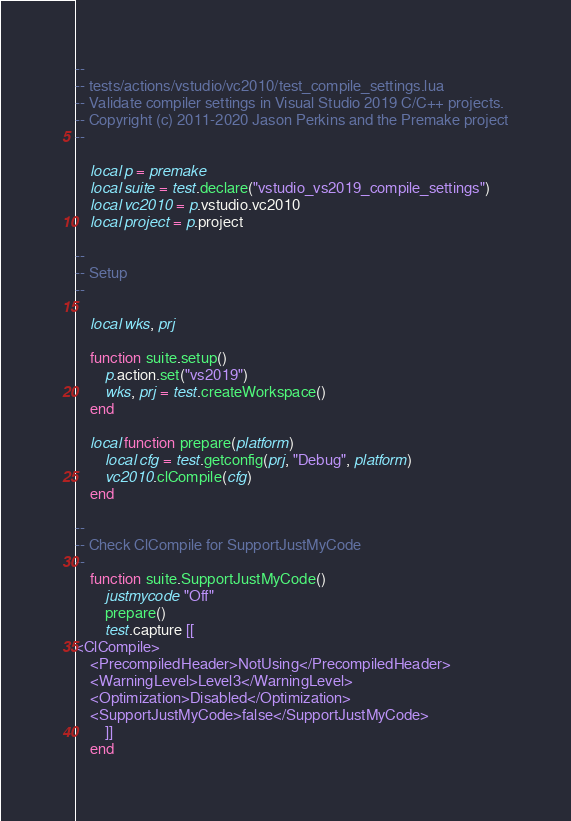<code> <loc_0><loc_0><loc_500><loc_500><_Lua_>--
-- tests/actions/vstudio/vc2010/test_compile_settings.lua
-- Validate compiler settings in Visual Studio 2019 C/C++ projects.
-- Copyright (c) 2011-2020 Jason Perkins and the Premake project
--

	local p = premake
	local suite = test.declare("vstudio_vs2019_compile_settings")
	local vc2010 = p.vstudio.vc2010
	local project = p.project

--
-- Setup
--

	local wks, prj

	function suite.setup()
		p.action.set("vs2019")
		wks, prj = test.createWorkspace()
	end

	local function prepare(platform)
		local cfg = test.getconfig(prj, "Debug", platform)
		vc2010.clCompile(cfg)
	end

--
-- Check ClCompile for SupportJustMyCode
--
	function suite.SupportJustMyCode()
		justmycode "Off"
		prepare()
		test.capture [[
<ClCompile>
	<PrecompiledHeader>NotUsing</PrecompiledHeader>
	<WarningLevel>Level3</WarningLevel>
	<Optimization>Disabled</Optimization>
	<SupportJustMyCode>false</SupportJustMyCode>
		]]
	end</code> 